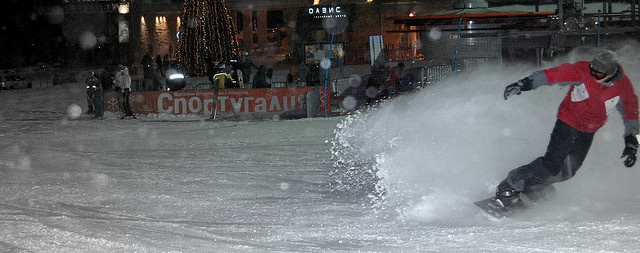Describe the objects in this image and their specific colors. I can see people in black, maroon, gray, and darkgray tones, snowboard in black and gray tones, people in black, gray, and darkgray tones, people in black, gray, darkgray, and white tones, and people in black, gray, and maroon tones in this image. 